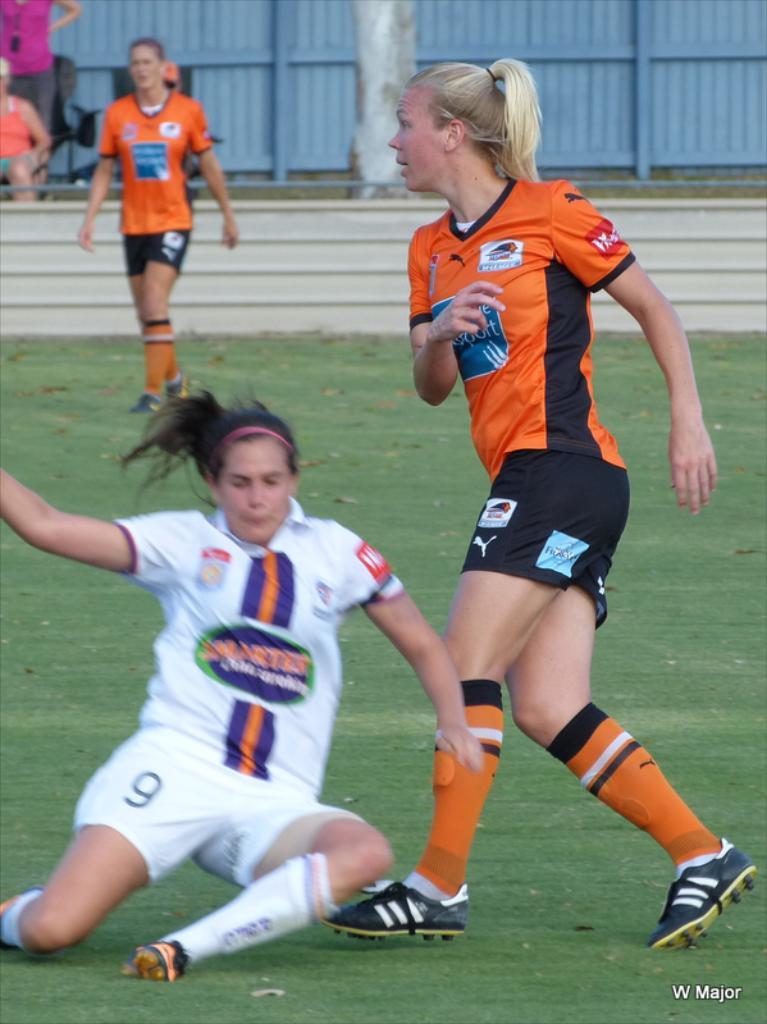What word is in the bottom right?
Provide a short and direct response. Major. What number is on the womans shorts in white?
Offer a terse response. 9. 